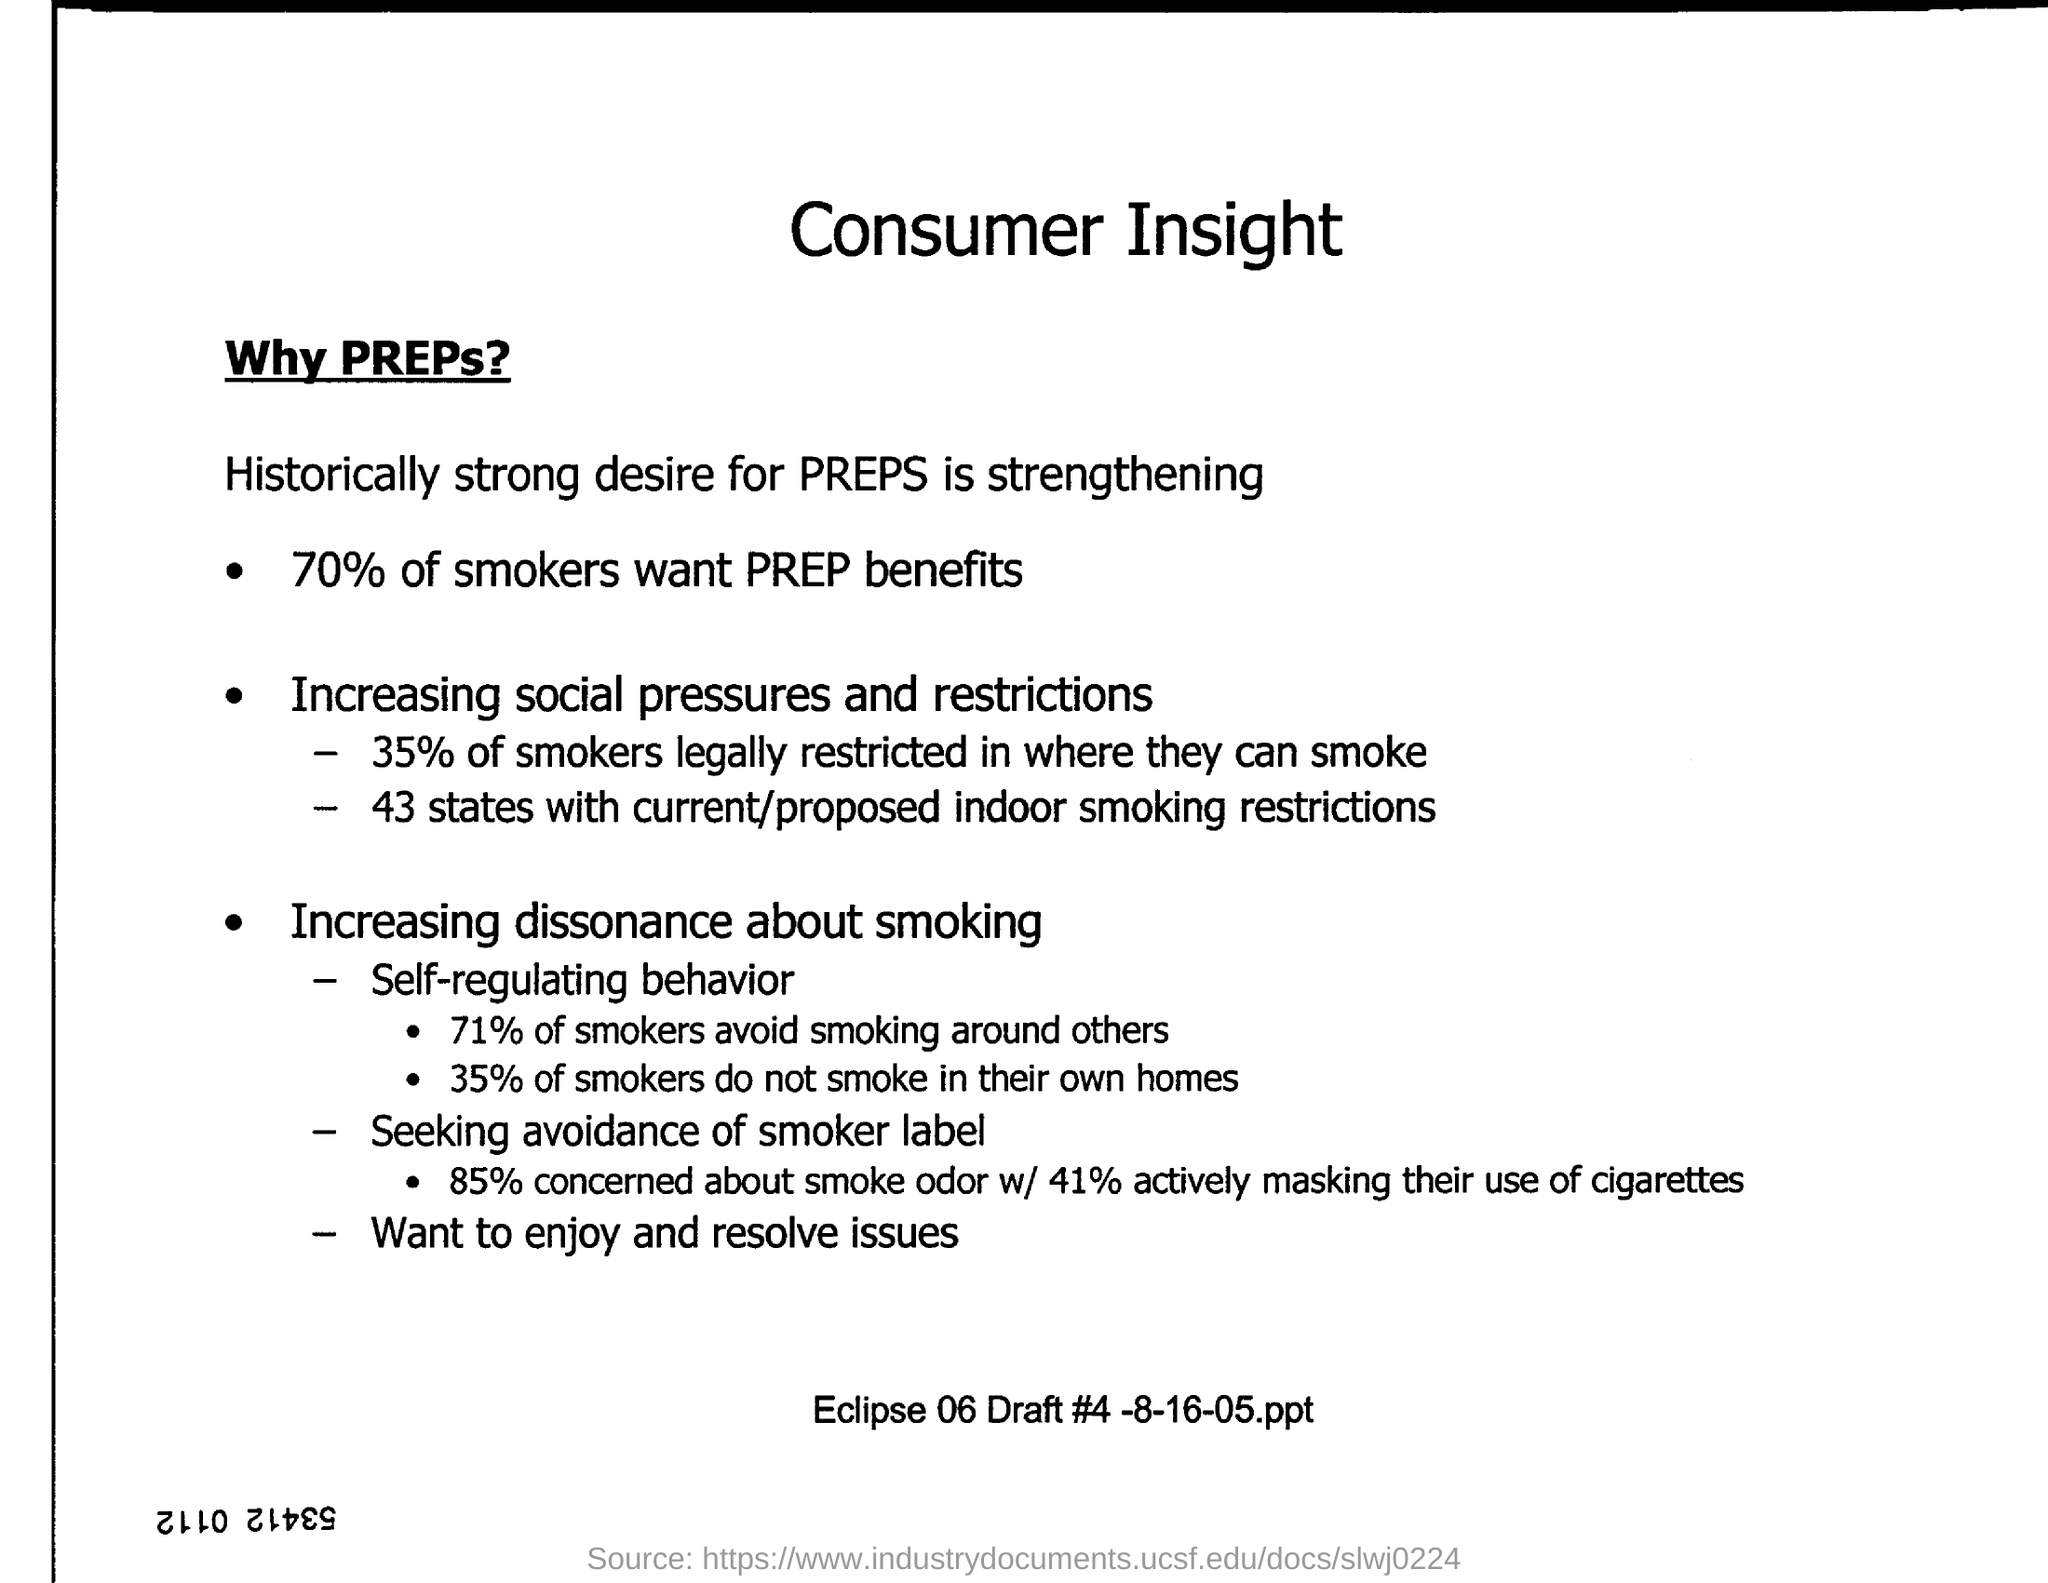What is the main heading of the document?
Your answer should be very brief. Consumer Insight. How many % of smokers want PREP benefits?
Ensure brevity in your answer.  70%. How many % of smokers legally restricted in where they can smoke?
Your response must be concise. 35. How many states have current/proposed indoor smoking restrictions?
Ensure brevity in your answer.  43. How the 71% of smokers manifest self-regulating behavior?
Provide a succinct answer. Avoid smoking around others. How many % of smokers do not smoke in their own homes?
Your answer should be very brief. 35. How many % of smokers actively masking their use of cigarettes?
Offer a very short reply. 41%. 